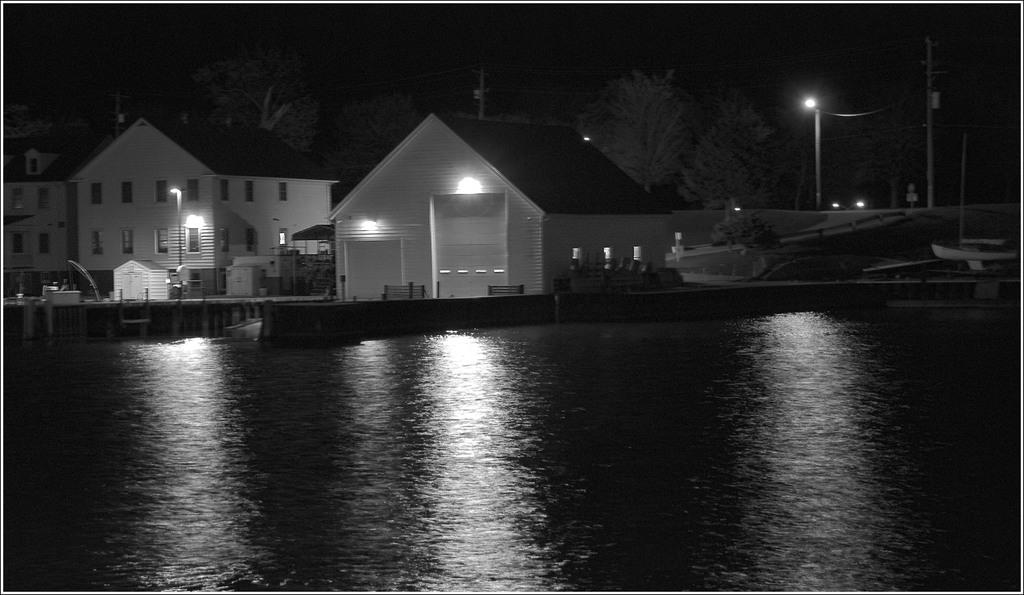What is visible in the foreground of the image? There is a water surface in the foreground of the image. What can be seen in the background of the image? There are houses, lamp poles, and trees in the background of the image. Is there a cemetery visible in the image? There is no mention of a cemetery in the provided facts, so it cannot be determined if one is present in the image. What subject is being taught in the image? There is no indication of any teaching or educational activity in the image. 